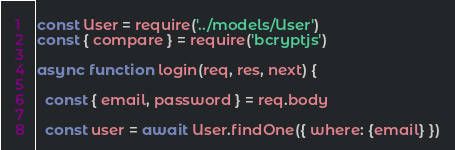Convert code to text. <code><loc_0><loc_0><loc_500><loc_500><_JavaScript_>const User = require('../models/User')
const { compare } = require('bcryptjs')

async function login(req, res, next) {

  const { email, password } = req.body

  const user = await User.findOne({ where: {email} })
</code> 